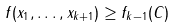Convert formula to latex. <formula><loc_0><loc_0><loc_500><loc_500>f ( x _ { 1 } , \dots , x _ { k + 1 } ) \geq f _ { k - 1 } ( C )</formula> 